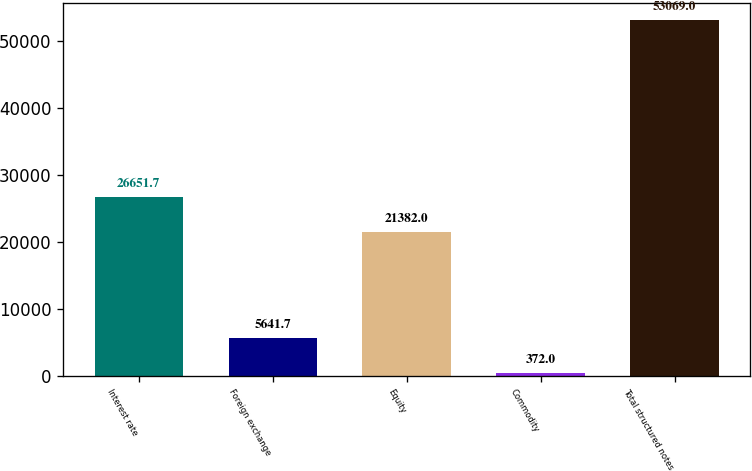Convert chart. <chart><loc_0><loc_0><loc_500><loc_500><bar_chart><fcel>Interest rate<fcel>Foreign exchange<fcel>Equity<fcel>Commodity<fcel>Total structured notes<nl><fcel>26651.7<fcel>5641.7<fcel>21382<fcel>372<fcel>53069<nl></chart> 